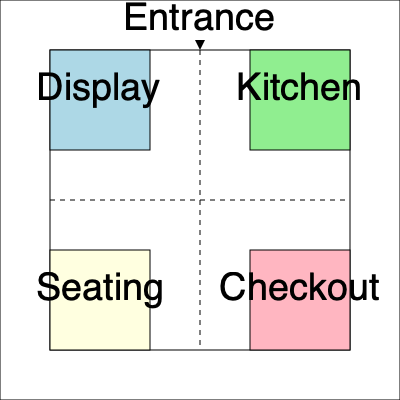Given the floor plan of a bakery shown above, which layout configuration would optimize customer flow and efficiency? Consider factors such as the placement of the display area, kitchen, seating, and checkout counter in relation to the entrance. To optimize customer flow and efficiency in the bakery, we need to consider several factors:

1. Entrance placement: The entrance is currently at the top center of the layout, which is ideal for dividing customer traffic.

2. Display area: Ideally, this should be the first thing customers see upon entering. In the current layout, it's in the top-left quadrant, which is good.

3. Kitchen proximity: The kitchen (top-right quadrant) is close to the display area, which is efficient for restocking.

4. Seating area: Currently in the bottom-left quadrant, it's away from the immediate entrance area, which is good for creating a relaxed atmosphere.

5. Checkout counter: Positioned in the bottom-right quadrant, it's the last stop before exiting, which is optimal.

To optimize the layout:

a) Keep the display area (top-left) and kitchen (top-right) in their current positions. This allows for efficient restocking and immediate visibility of products.

b) Swap the positions of the seating area and checkout counter. Place the checkout counter in the bottom-left quadrant and the seating area in the bottom-right quadrant.

This configuration would create a natural clockwise flow:
1. Customers enter and immediately see the display area.
2. They move right to make selections.
3. They proceed to the checkout counter in the bottom-left.
4. If they choose to stay, they can move to the seating area in the bottom-right.

This layout minimizes cross-traffic and creates a more efficient customer flow, reducing congestion and improving the overall customer experience.
Answer: Swap seating and checkout areas for clockwise flow: Display → Selection → Checkout → Optional Seating. 